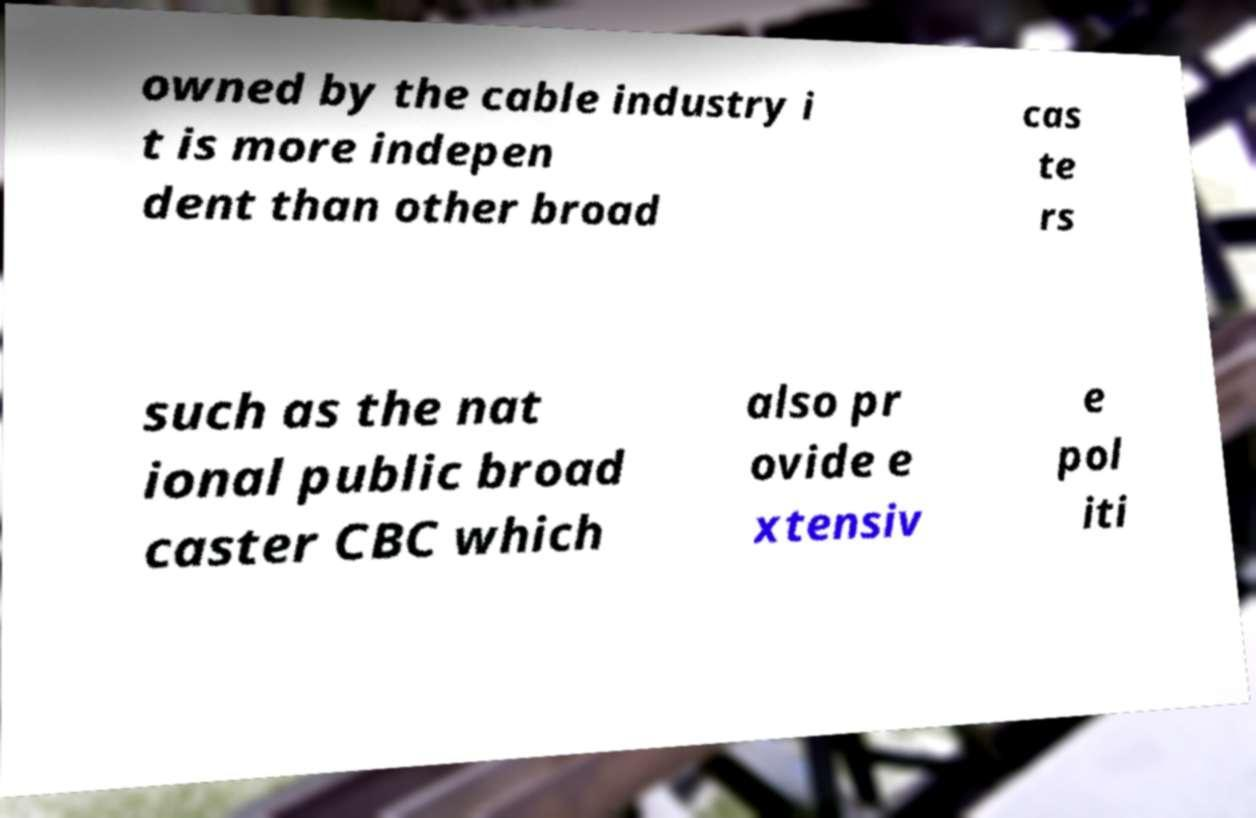Could you extract and type out the text from this image? owned by the cable industry i t is more indepen dent than other broad cas te rs such as the nat ional public broad caster CBC which also pr ovide e xtensiv e pol iti 